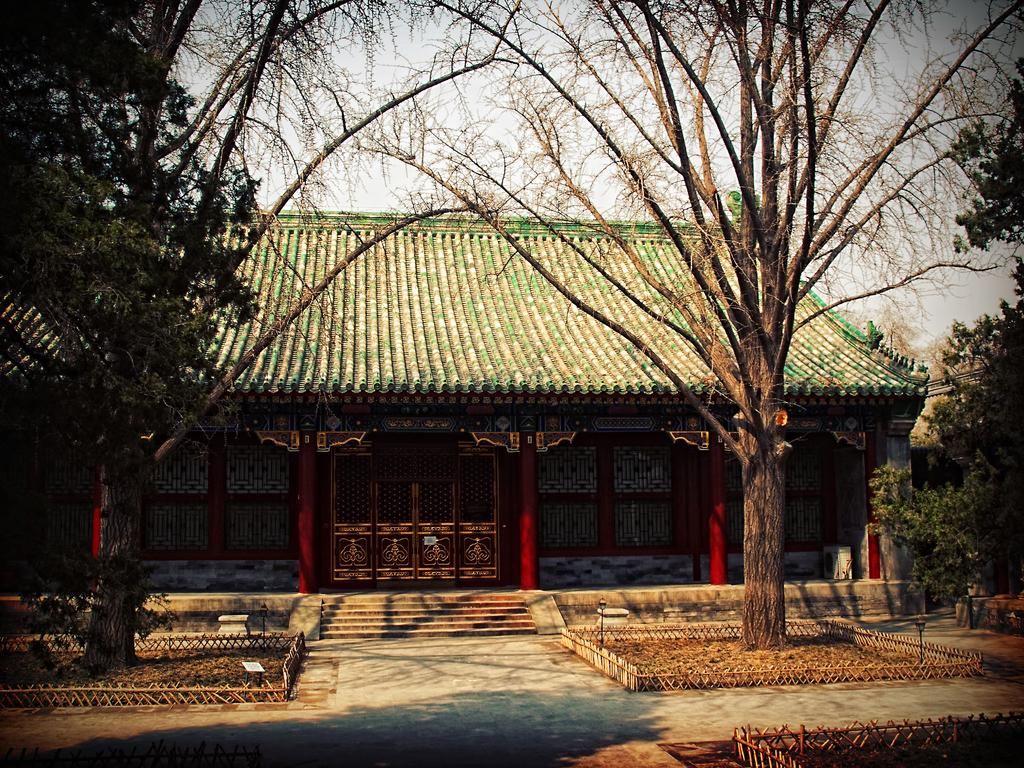What type of structure is visible in the image? There is a house in the image. What are some features of the house? The house has a roof, pillars, and a staircase. What is located near the house? There is a wooden fence and trees in the image. What else can be seen in the image? There are poles in the image, and the sky is visible. How would you describe the sky in the image? The sky appears cloudy in the image. Can you see any fingers holding a yoke in the image? There are no fingers or yokes present in the image. Is there any lettuce growing in the image? There is no lettuce visible in the image. 